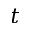Convert formula to latex. <formula><loc_0><loc_0><loc_500><loc_500>t</formula> 